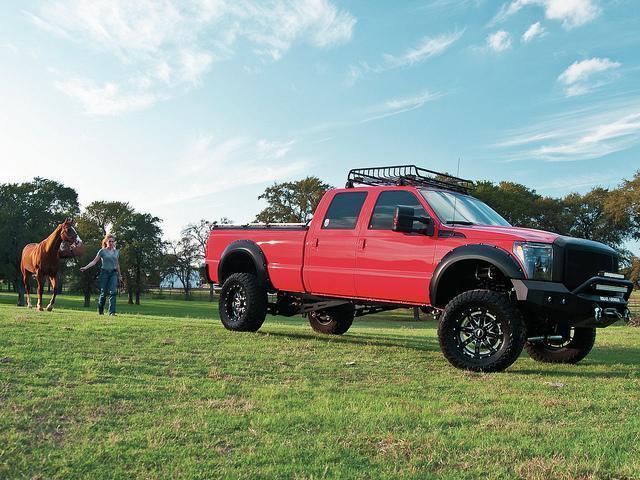Is the caption "The horse is behind the truck." a true representation of the image?
Answer yes or no. Yes. 